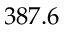Convert formula to latex. <formula><loc_0><loc_0><loc_500><loc_500>3 8 7 . 6</formula> 